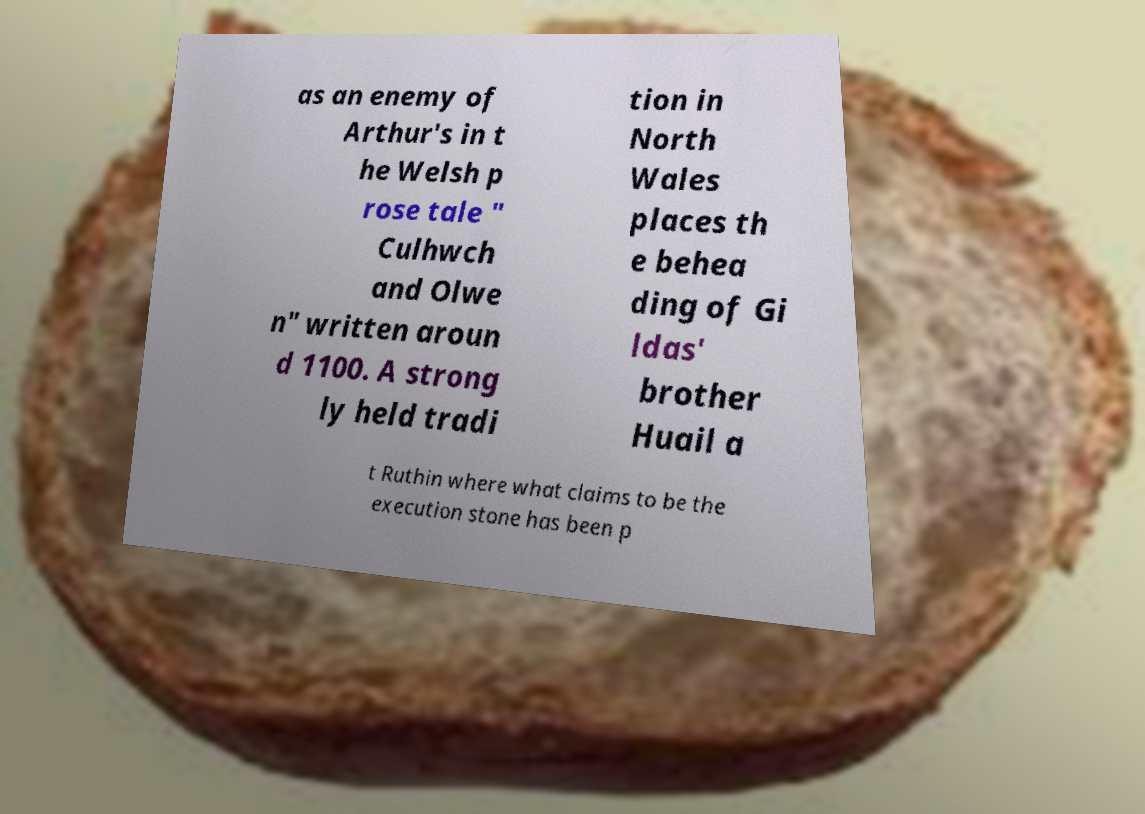What can you tell me about the story of 'Culhwch and Olwen'? 'Culhwch and Olwen' is one of the earliest Welsh prose tales and an integral part of the Mabinogion, a collection of medieval Welsh tales. The story revolves around Culhwch's quest to win Olwen's hand in marriage, which involves completing a series of impossible tasks set by her father, Ysbaddaden Bencawr, a giant. King Arthur and his knights feature as supporting characters that assist Culhwch in his quest. 